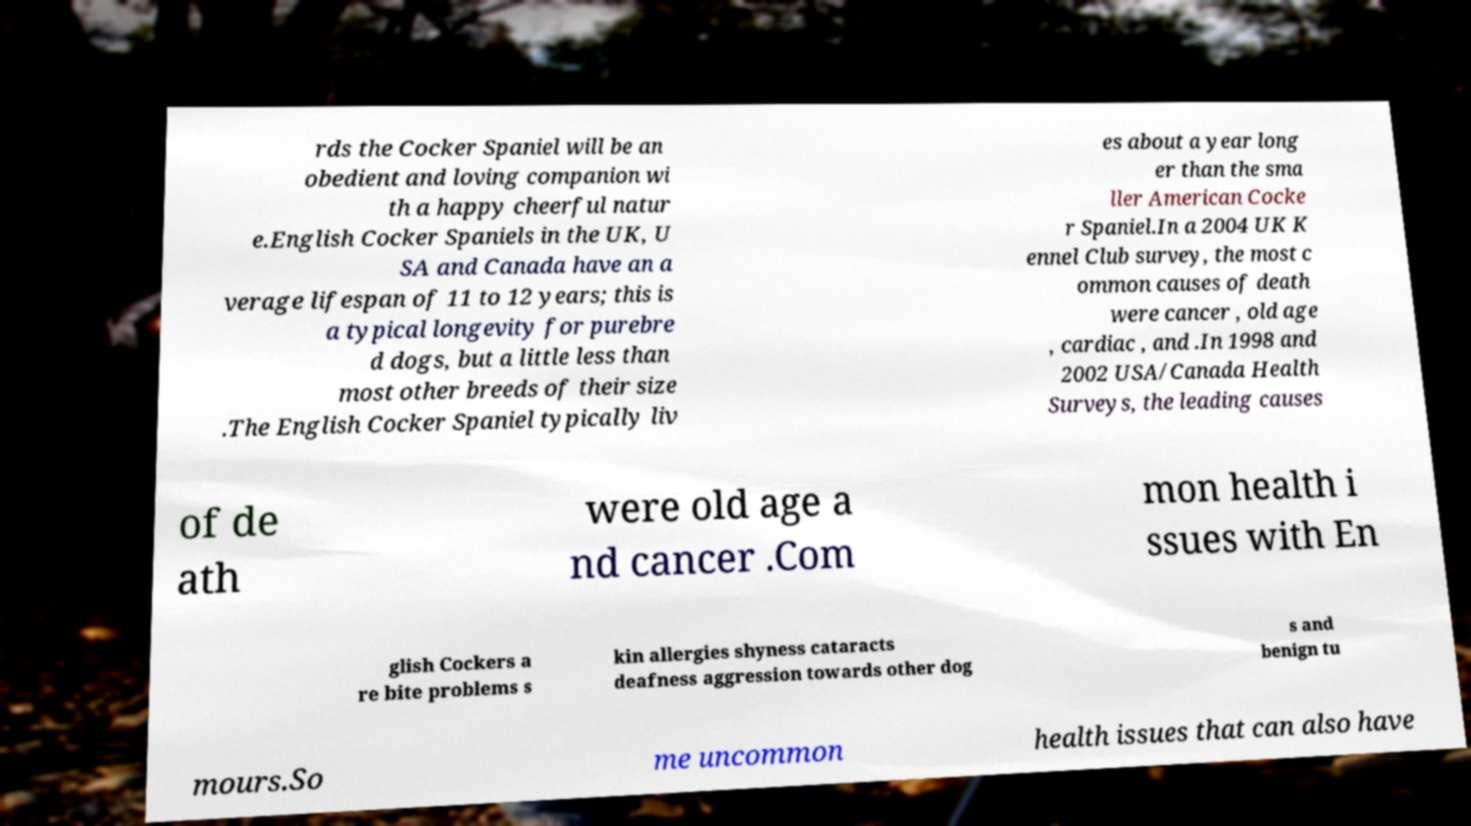Can you read and provide the text displayed in the image?This photo seems to have some interesting text. Can you extract and type it out for me? rds the Cocker Spaniel will be an obedient and loving companion wi th a happy cheerful natur e.English Cocker Spaniels in the UK, U SA and Canada have an a verage lifespan of 11 to 12 years; this is a typical longevity for purebre d dogs, but a little less than most other breeds of their size .The English Cocker Spaniel typically liv es about a year long er than the sma ller American Cocke r Spaniel.In a 2004 UK K ennel Club survey, the most c ommon causes of death were cancer , old age , cardiac , and .In 1998 and 2002 USA/Canada Health Surveys, the leading causes of de ath were old age a nd cancer .Com mon health i ssues with En glish Cockers a re bite problems s kin allergies shyness cataracts deafness aggression towards other dog s and benign tu mours.So me uncommon health issues that can also have 